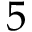Convert formula to latex. <formula><loc_0><loc_0><loc_500><loc_500>5</formula> 